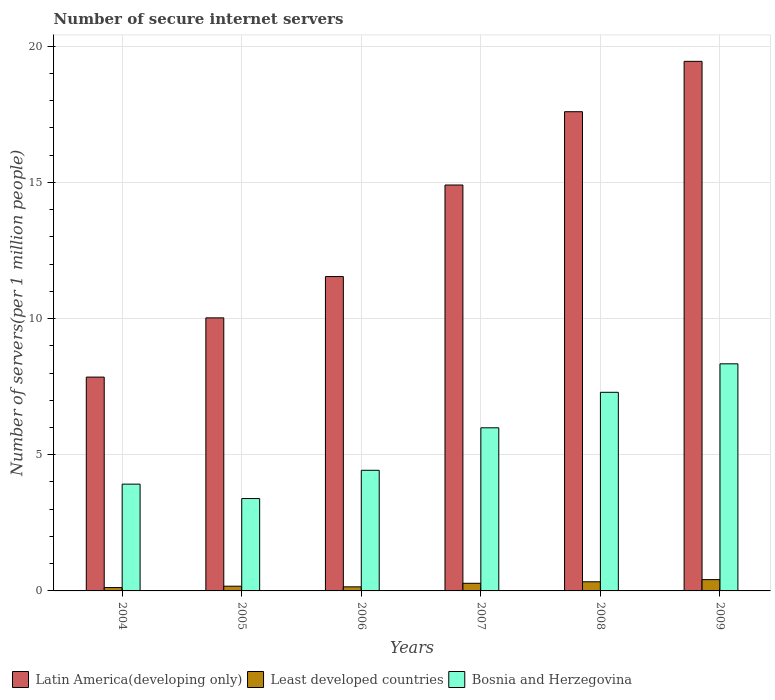How many different coloured bars are there?
Give a very brief answer. 3. Are the number of bars per tick equal to the number of legend labels?
Your response must be concise. Yes. In how many cases, is the number of bars for a given year not equal to the number of legend labels?
Make the answer very short. 0. What is the number of secure internet servers in Latin America(developing only) in 2005?
Provide a succinct answer. 10.03. Across all years, what is the maximum number of secure internet servers in Bosnia and Herzegovina?
Your answer should be compact. 8.34. Across all years, what is the minimum number of secure internet servers in Bosnia and Herzegovina?
Provide a short and direct response. 3.39. In which year was the number of secure internet servers in Least developed countries minimum?
Keep it short and to the point. 2004. What is the total number of secure internet servers in Least developed countries in the graph?
Your response must be concise. 1.48. What is the difference between the number of secure internet servers in Least developed countries in 2004 and that in 2006?
Make the answer very short. -0.03. What is the difference between the number of secure internet servers in Least developed countries in 2008 and the number of secure internet servers in Bosnia and Herzegovina in 2009?
Provide a short and direct response. -8. What is the average number of secure internet servers in Latin America(developing only) per year?
Your answer should be very brief. 13.56. In the year 2004, what is the difference between the number of secure internet servers in Latin America(developing only) and number of secure internet servers in Least developed countries?
Make the answer very short. 7.73. In how many years, is the number of secure internet servers in Latin America(developing only) greater than 4?
Your answer should be compact. 6. What is the ratio of the number of secure internet servers in Least developed countries in 2005 to that in 2008?
Provide a short and direct response. 0.52. What is the difference between the highest and the second highest number of secure internet servers in Least developed countries?
Your response must be concise. 0.08. What is the difference between the highest and the lowest number of secure internet servers in Latin America(developing only)?
Your answer should be compact. 11.59. What does the 1st bar from the left in 2005 represents?
Ensure brevity in your answer.  Latin America(developing only). What does the 1st bar from the right in 2006 represents?
Your answer should be compact. Bosnia and Herzegovina. How many bars are there?
Ensure brevity in your answer.  18. Does the graph contain any zero values?
Make the answer very short. No. What is the title of the graph?
Your answer should be very brief. Number of secure internet servers. What is the label or title of the X-axis?
Your answer should be very brief. Years. What is the label or title of the Y-axis?
Make the answer very short. Number of servers(per 1 million people). What is the Number of servers(per 1 million people) of Latin America(developing only) in 2004?
Offer a terse response. 7.85. What is the Number of servers(per 1 million people) of Least developed countries in 2004?
Your answer should be compact. 0.12. What is the Number of servers(per 1 million people) in Bosnia and Herzegovina in 2004?
Your answer should be compact. 3.92. What is the Number of servers(per 1 million people) in Latin America(developing only) in 2005?
Your answer should be very brief. 10.03. What is the Number of servers(per 1 million people) of Least developed countries in 2005?
Keep it short and to the point. 0.17. What is the Number of servers(per 1 million people) in Bosnia and Herzegovina in 2005?
Your answer should be compact. 3.39. What is the Number of servers(per 1 million people) in Latin America(developing only) in 2006?
Provide a succinct answer. 11.54. What is the Number of servers(per 1 million people) of Least developed countries in 2006?
Ensure brevity in your answer.  0.15. What is the Number of servers(per 1 million people) of Bosnia and Herzegovina in 2006?
Ensure brevity in your answer.  4.43. What is the Number of servers(per 1 million people) of Latin America(developing only) in 2007?
Keep it short and to the point. 14.9. What is the Number of servers(per 1 million people) in Least developed countries in 2007?
Provide a succinct answer. 0.28. What is the Number of servers(per 1 million people) of Bosnia and Herzegovina in 2007?
Offer a terse response. 5.99. What is the Number of servers(per 1 million people) in Latin America(developing only) in 2008?
Provide a short and direct response. 17.59. What is the Number of servers(per 1 million people) in Least developed countries in 2008?
Make the answer very short. 0.34. What is the Number of servers(per 1 million people) of Bosnia and Herzegovina in 2008?
Provide a short and direct response. 7.29. What is the Number of servers(per 1 million people) of Latin America(developing only) in 2009?
Make the answer very short. 19.44. What is the Number of servers(per 1 million people) in Least developed countries in 2009?
Your answer should be very brief. 0.42. What is the Number of servers(per 1 million people) of Bosnia and Herzegovina in 2009?
Your answer should be very brief. 8.34. Across all years, what is the maximum Number of servers(per 1 million people) in Latin America(developing only)?
Offer a terse response. 19.44. Across all years, what is the maximum Number of servers(per 1 million people) of Least developed countries?
Offer a very short reply. 0.42. Across all years, what is the maximum Number of servers(per 1 million people) in Bosnia and Herzegovina?
Your answer should be very brief. 8.34. Across all years, what is the minimum Number of servers(per 1 million people) of Latin America(developing only)?
Make the answer very short. 7.85. Across all years, what is the minimum Number of servers(per 1 million people) of Least developed countries?
Make the answer very short. 0.12. Across all years, what is the minimum Number of servers(per 1 million people) in Bosnia and Herzegovina?
Offer a terse response. 3.39. What is the total Number of servers(per 1 million people) in Latin America(developing only) in the graph?
Offer a very short reply. 81.36. What is the total Number of servers(per 1 million people) in Least developed countries in the graph?
Your answer should be compact. 1.48. What is the total Number of servers(per 1 million people) in Bosnia and Herzegovina in the graph?
Offer a very short reply. 33.36. What is the difference between the Number of servers(per 1 million people) in Latin America(developing only) in 2004 and that in 2005?
Ensure brevity in your answer.  -2.17. What is the difference between the Number of servers(per 1 million people) in Least developed countries in 2004 and that in 2005?
Keep it short and to the point. -0.05. What is the difference between the Number of servers(per 1 million people) in Bosnia and Herzegovina in 2004 and that in 2005?
Ensure brevity in your answer.  0.53. What is the difference between the Number of servers(per 1 million people) of Latin America(developing only) in 2004 and that in 2006?
Provide a succinct answer. -3.69. What is the difference between the Number of servers(per 1 million people) in Least developed countries in 2004 and that in 2006?
Provide a short and direct response. -0.03. What is the difference between the Number of servers(per 1 million people) of Bosnia and Herzegovina in 2004 and that in 2006?
Keep it short and to the point. -0.51. What is the difference between the Number of servers(per 1 million people) in Latin America(developing only) in 2004 and that in 2007?
Give a very brief answer. -7.05. What is the difference between the Number of servers(per 1 million people) in Least developed countries in 2004 and that in 2007?
Provide a succinct answer. -0.16. What is the difference between the Number of servers(per 1 million people) in Bosnia and Herzegovina in 2004 and that in 2007?
Your response must be concise. -2.07. What is the difference between the Number of servers(per 1 million people) of Latin America(developing only) in 2004 and that in 2008?
Give a very brief answer. -9.74. What is the difference between the Number of servers(per 1 million people) of Least developed countries in 2004 and that in 2008?
Provide a succinct answer. -0.21. What is the difference between the Number of servers(per 1 million people) in Bosnia and Herzegovina in 2004 and that in 2008?
Provide a short and direct response. -3.37. What is the difference between the Number of servers(per 1 million people) in Latin America(developing only) in 2004 and that in 2009?
Provide a succinct answer. -11.59. What is the difference between the Number of servers(per 1 million people) in Least developed countries in 2004 and that in 2009?
Offer a terse response. -0.29. What is the difference between the Number of servers(per 1 million people) of Bosnia and Herzegovina in 2004 and that in 2009?
Offer a terse response. -4.42. What is the difference between the Number of servers(per 1 million people) in Latin America(developing only) in 2005 and that in 2006?
Provide a succinct answer. -1.52. What is the difference between the Number of servers(per 1 million people) of Least developed countries in 2005 and that in 2006?
Offer a terse response. 0.02. What is the difference between the Number of servers(per 1 million people) of Bosnia and Herzegovina in 2005 and that in 2006?
Your response must be concise. -1.04. What is the difference between the Number of servers(per 1 million people) in Latin America(developing only) in 2005 and that in 2007?
Keep it short and to the point. -4.88. What is the difference between the Number of servers(per 1 million people) in Least developed countries in 2005 and that in 2007?
Provide a succinct answer. -0.11. What is the difference between the Number of servers(per 1 million people) in Bosnia and Herzegovina in 2005 and that in 2007?
Your answer should be compact. -2.6. What is the difference between the Number of servers(per 1 million people) in Latin America(developing only) in 2005 and that in 2008?
Your answer should be compact. -7.57. What is the difference between the Number of servers(per 1 million people) in Least developed countries in 2005 and that in 2008?
Your answer should be compact. -0.16. What is the difference between the Number of servers(per 1 million people) of Bosnia and Herzegovina in 2005 and that in 2008?
Your response must be concise. -3.9. What is the difference between the Number of servers(per 1 million people) of Latin America(developing only) in 2005 and that in 2009?
Your answer should be very brief. -9.42. What is the difference between the Number of servers(per 1 million people) in Least developed countries in 2005 and that in 2009?
Offer a terse response. -0.24. What is the difference between the Number of servers(per 1 million people) of Bosnia and Herzegovina in 2005 and that in 2009?
Offer a terse response. -4.95. What is the difference between the Number of servers(per 1 million people) of Latin America(developing only) in 2006 and that in 2007?
Ensure brevity in your answer.  -3.36. What is the difference between the Number of servers(per 1 million people) of Least developed countries in 2006 and that in 2007?
Ensure brevity in your answer.  -0.13. What is the difference between the Number of servers(per 1 million people) of Bosnia and Herzegovina in 2006 and that in 2007?
Give a very brief answer. -1.56. What is the difference between the Number of servers(per 1 million people) in Latin America(developing only) in 2006 and that in 2008?
Provide a short and direct response. -6.05. What is the difference between the Number of servers(per 1 million people) in Least developed countries in 2006 and that in 2008?
Your response must be concise. -0.19. What is the difference between the Number of servers(per 1 million people) of Bosnia and Herzegovina in 2006 and that in 2008?
Your answer should be compact. -2.86. What is the difference between the Number of servers(per 1 million people) of Latin America(developing only) in 2006 and that in 2009?
Provide a short and direct response. -7.9. What is the difference between the Number of servers(per 1 million people) in Least developed countries in 2006 and that in 2009?
Offer a very short reply. -0.27. What is the difference between the Number of servers(per 1 million people) of Bosnia and Herzegovina in 2006 and that in 2009?
Ensure brevity in your answer.  -3.91. What is the difference between the Number of servers(per 1 million people) in Latin America(developing only) in 2007 and that in 2008?
Offer a terse response. -2.69. What is the difference between the Number of servers(per 1 million people) in Least developed countries in 2007 and that in 2008?
Your response must be concise. -0.06. What is the difference between the Number of servers(per 1 million people) of Bosnia and Herzegovina in 2007 and that in 2008?
Offer a very short reply. -1.3. What is the difference between the Number of servers(per 1 million people) in Latin America(developing only) in 2007 and that in 2009?
Keep it short and to the point. -4.54. What is the difference between the Number of servers(per 1 million people) in Least developed countries in 2007 and that in 2009?
Offer a very short reply. -0.13. What is the difference between the Number of servers(per 1 million people) of Bosnia and Herzegovina in 2007 and that in 2009?
Give a very brief answer. -2.35. What is the difference between the Number of servers(per 1 million people) in Latin America(developing only) in 2008 and that in 2009?
Your answer should be very brief. -1.85. What is the difference between the Number of servers(per 1 million people) in Least developed countries in 2008 and that in 2009?
Provide a short and direct response. -0.08. What is the difference between the Number of servers(per 1 million people) of Bosnia and Herzegovina in 2008 and that in 2009?
Provide a succinct answer. -1.05. What is the difference between the Number of servers(per 1 million people) of Latin America(developing only) in 2004 and the Number of servers(per 1 million people) of Least developed countries in 2005?
Your response must be concise. 7.68. What is the difference between the Number of servers(per 1 million people) of Latin America(developing only) in 2004 and the Number of servers(per 1 million people) of Bosnia and Herzegovina in 2005?
Your answer should be compact. 4.46. What is the difference between the Number of servers(per 1 million people) in Least developed countries in 2004 and the Number of servers(per 1 million people) in Bosnia and Herzegovina in 2005?
Keep it short and to the point. -3.27. What is the difference between the Number of servers(per 1 million people) of Latin America(developing only) in 2004 and the Number of servers(per 1 million people) of Least developed countries in 2006?
Give a very brief answer. 7.7. What is the difference between the Number of servers(per 1 million people) of Latin America(developing only) in 2004 and the Number of servers(per 1 million people) of Bosnia and Herzegovina in 2006?
Offer a very short reply. 3.42. What is the difference between the Number of servers(per 1 million people) in Least developed countries in 2004 and the Number of servers(per 1 million people) in Bosnia and Herzegovina in 2006?
Your answer should be very brief. -4.31. What is the difference between the Number of servers(per 1 million people) of Latin America(developing only) in 2004 and the Number of servers(per 1 million people) of Least developed countries in 2007?
Provide a short and direct response. 7.57. What is the difference between the Number of servers(per 1 million people) of Latin America(developing only) in 2004 and the Number of servers(per 1 million people) of Bosnia and Herzegovina in 2007?
Keep it short and to the point. 1.86. What is the difference between the Number of servers(per 1 million people) in Least developed countries in 2004 and the Number of servers(per 1 million people) in Bosnia and Herzegovina in 2007?
Offer a terse response. -5.87. What is the difference between the Number of servers(per 1 million people) in Latin America(developing only) in 2004 and the Number of servers(per 1 million people) in Least developed countries in 2008?
Make the answer very short. 7.52. What is the difference between the Number of servers(per 1 million people) in Latin America(developing only) in 2004 and the Number of servers(per 1 million people) in Bosnia and Herzegovina in 2008?
Make the answer very short. 0.56. What is the difference between the Number of servers(per 1 million people) of Least developed countries in 2004 and the Number of servers(per 1 million people) of Bosnia and Herzegovina in 2008?
Your answer should be compact. -7.17. What is the difference between the Number of servers(per 1 million people) in Latin America(developing only) in 2004 and the Number of servers(per 1 million people) in Least developed countries in 2009?
Provide a succinct answer. 7.44. What is the difference between the Number of servers(per 1 million people) in Latin America(developing only) in 2004 and the Number of servers(per 1 million people) in Bosnia and Herzegovina in 2009?
Keep it short and to the point. -0.49. What is the difference between the Number of servers(per 1 million people) in Least developed countries in 2004 and the Number of servers(per 1 million people) in Bosnia and Herzegovina in 2009?
Offer a terse response. -8.21. What is the difference between the Number of servers(per 1 million people) of Latin America(developing only) in 2005 and the Number of servers(per 1 million people) of Least developed countries in 2006?
Your answer should be very brief. 9.88. What is the difference between the Number of servers(per 1 million people) of Latin America(developing only) in 2005 and the Number of servers(per 1 million people) of Bosnia and Herzegovina in 2006?
Provide a succinct answer. 5.6. What is the difference between the Number of servers(per 1 million people) of Least developed countries in 2005 and the Number of servers(per 1 million people) of Bosnia and Herzegovina in 2006?
Ensure brevity in your answer.  -4.26. What is the difference between the Number of servers(per 1 million people) in Latin America(developing only) in 2005 and the Number of servers(per 1 million people) in Least developed countries in 2007?
Make the answer very short. 9.74. What is the difference between the Number of servers(per 1 million people) of Latin America(developing only) in 2005 and the Number of servers(per 1 million people) of Bosnia and Herzegovina in 2007?
Provide a short and direct response. 4.04. What is the difference between the Number of servers(per 1 million people) in Least developed countries in 2005 and the Number of servers(per 1 million people) in Bosnia and Herzegovina in 2007?
Your answer should be very brief. -5.82. What is the difference between the Number of servers(per 1 million people) in Latin America(developing only) in 2005 and the Number of servers(per 1 million people) in Least developed countries in 2008?
Your answer should be very brief. 9.69. What is the difference between the Number of servers(per 1 million people) of Latin America(developing only) in 2005 and the Number of servers(per 1 million people) of Bosnia and Herzegovina in 2008?
Ensure brevity in your answer.  2.73. What is the difference between the Number of servers(per 1 million people) in Least developed countries in 2005 and the Number of servers(per 1 million people) in Bosnia and Herzegovina in 2008?
Give a very brief answer. -7.12. What is the difference between the Number of servers(per 1 million people) of Latin America(developing only) in 2005 and the Number of servers(per 1 million people) of Least developed countries in 2009?
Your answer should be very brief. 9.61. What is the difference between the Number of servers(per 1 million people) in Latin America(developing only) in 2005 and the Number of servers(per 1 million people) in Bosnia and Herzegovina in 2009?
Ensure brevity in your answer.  1.69. What is the difference between the Number of servers(per 1 million people) of Least developed countries in 2005 and the Number of servers(per 1 million people) of Bosnia and Herzegovina in 2009?
Make the answer very short. -8.16. What is the difference between the Number of servers(per 1 million people) of Latin America(developing only) in 2006 and the Number of servers(per 1 million people) of Least developed countries in 2007?
Your answer should be very brief. 11.26. What is the difference between the Number of servers(per 1 million people) in Latin America(developing only) in 2006 and the Number of servers(per 1 million people) in Bosnia and Herzegovina in 2007?
Keep it short and to the point. 5.55. What is the difference between the Number of servers(per 1 million people) in Least developed countries in 2006 and the Number of servers(per 1 million people) in Bosnia and Herzegovina in 2007?
Keep it short and to the point. -5.84. What is the difference between the Number of servers(per 1 million people) of Latin America(developing only) in 2006 and the Number of servers(per 1 million people) of Least developed countries in 2008?
Provide a short and direct response. 11.21. What is the difference between the Number of servers(per 1 million people) of Latin America(developing only) in 2006 and the Number of servers(per 1 million people) of Bosnia and Herzegovina in 2008?
Your answer should be compact. 4.25. What is the difference between the Number of servers(per 1 million people) of Least developed countries in 2006 and the Number of servers(per 1 million people) of Bosnia and Herzegovina in 2008?
Your answer should be compact. -7.14. What is the difference between the Number of servers(per 1 million people) in Latin America(developing only) in 2006 and the Number of servers(per 1 million people) in Least developed countries in 2009?
Keep it short and to the point. 11.13. What is the difference between the Number of servers(per 1 million people) of Latin America(developing only) in 2006 and the Number of servers(per 1 million people) of Bosnia and Herzegovina in 2009?
Your response must be concise. 3.2. What is the difference between the Number of servers(per 1 million people) of Least developed countries in 2006 and the Number of servers(per 1 million people) of Bosnia and Herzegovina in 2009?
Your response must be concise. -8.19. What is the difference between the Number of servers(per 1 million people) in Latin America(developing only) in 2007 and the Number of servers(per 1 million people) in Least developed countries in 2008?
Your response must be concise. 14.57. What is the difference between the Number of servers(per 1 million people) of Latin America(developing only) in 2007 and the Number of servers(per 1 million people) of Bosnia and Herzegovina in 2008?
Give a very brief answer. 7.61. What is the difference between the Number of servers(per 1 million people) in Least developed countries in 2007 and the Number of servers(per 1 million people) in Bosnia and Herzegovina in 2008?
Make the answer very short. -7.01. What is the difference between the Number of servers(per 1 million people) of Latin America(developing only) in 2007 and the Number of servers(per 1 million people) of Least developed countries in 2009?
Offer a terse response. 14.49. What is the difference between the Number of servers(per 1 million people) in Latin America(developing only) in 2007 and the Number of servers(per 1 million people) in Bosnia and Herzegovina in 2009?
Ensure brevity in your answer.  6.56. What is the difference between the Number of servers(per 1 million people) in Least developed countries in 2007 and the Number of servers(per 1 million people) in Bosnia and Herzegovina in 2009?
Provide a short and direct response. -8.06. What is the difference between the Number of servers(per 1 million people) of Latin America(developing only) in 2008 and the Number of servers(per 1 million people) of Least developed countries in 2009?
Your response must be concise. 17.18. What is the difference between the Number of servers(per 1 million people) of Latin America(developing only) in 2008 and the Number of servers(per 1 million people) of Bosnia and Herzegovina in 2009?
Your answer should be very brief. 9.26. What is the difference between the Number of servers(per 1 million people) in Least developed countries in 2008 and the Number of servers(per 1 million people) in Bosnia and Herzegovina in 2009?
Ensure brevity in your answer.  -8. What is the average Number of servers(per 1 million people) of Latin America(developing only) per year?
Make the answer very short. 13.56. What is the average Number of servers(per 1 million people) in Least developed countries per year?
Offer a very short reply. 0.25. What is the average Number of servers(per 1 million people) in Bosnia and Herzegovina per year?
Provide a short and direct response. 5.56. In the year 2004, what is the difference between the Number of servers(per 1 million people) of Latin America(developing only) and Number of servers(per 1 million people) of Least developed countries?
Ensure brevity in your answer.  7.73. In the year 2004, what is the difference between the Number of servers(per 1 million people) of Latin America(developing only) and Number of servers(per 1 million people) of Bosnia and Herzegovina?
Keep it short and to the point. 3.93. In the year 2004, what is the difference between the Number of servers(per 1 million people) of Least developed countries and Number of servers(per 1 million people) of Bosnia and Herzegovina?
Offer a terse response. -3.8. In the year 2005, what is the difference between the Number of servers(per 1 million people) of Latin America(developing only) and Number of servers(per 1 million people) of Least developed countries?
Provide a succinct answer. 9.85. In the year 2005, what is the difference between the Number of servers(per 1 million people) in Latin America(developing only) and Number of servers(per 1 million people) in Bosnia and Herzegovina?
Your answer should be very brief. 6.63. In the year 2005, what is the difference between the Number of servers(per 1 million people) of Least developed countries and Number of servers(per 1 million people) of Bosnia and Herzegovina?
Your response must be concise. -3.22. In the year 2006, what is the difference between the Number of servers(per 1 million people) of Latin America(developing only) and Number of servers(per 1 million people) of Least developed countries?
Offer a very short reply. 11.39. In the year 2006, what is the difference between the Number of servers(per 1 million people) of Latin America(developing only) and Number of servers(per 1 million people) of Bosnia and Herzegovina?
Your response must be concise. 7.11. In the year 2006, what is the difference between the Number of servers(per 1 million people) of Least developed countries and Number of servers(per 1 million people) of Bosnia and Herzegovina?
Your answer should be compact. -4.28. In the year 2007, what is the difference between the Number of servers(per 1 million people) in Latin America(developing only) and Number of servers(per 1 million people) in Least developed countries?
Your response must be concise. 14.62. In the year 2007, what is the difference between the Number of servers(per 1 million people) in Latin America(developing only) and Number of servers(per 1 million people) in Bosnia and Herzegovina?
Your answer should be compact. 8.91. In the year 2007, what is the difference between the Number of servers(per 1 million people) in Least developed countries and Number of servers(per 1 million people) in Bosnia and Herzegovina?
Provide a succinct answer. -5.71. In the year 2008, what is the difference between the Number of servers(per 1 million people) in Latin America(developing only) and Number of servers(per 1 million people) in Least developed countries?
Offer a very short reply. 17.26. In the year 2008, what is the difference between the Number of servers(per 1 million people) in Latin America(developing only) and Number of servers(per 1 million people) in Bosnia and Herzegovina?
Provide a short and direct response. 10.3. In the year 2008, what is the difference between the Number of servers(per 1 million people) of Least developed countries and Number of servers(per 1 million people) of Bosnia and Herzegovina?
Your response must be concise. -6.96. In the year 2009, what is the difference between the Number of servers(per 1 million people) in Latin America(developing only) and Number of servers(per 1 million people) in Least developed countries?
Your answer should be compact. 19.03. In the year 2009, what is the difference between the Number of servers(per 1 million people) in Latin America(developing only) and Number of servers(per 1 million people) in Bosnia and Herzegovina?
Offer a very short reply. 11.1. In the year 2009, what is the difference between the Number of servers(per 1 million people) in Least developed countries and Number of servers(per 1 million people) in Bosnia and Herzegovina?
Offer a terse response. -7.92. What is the ratio of the Number of servers(per 1 million people) of Latin America(developing only) in 2004 to that in 2005?
Your response must be concise. 0.78. What is the ratio of the Number of servers(per 1 million people) in Least developed countries in 2004 to that in 2005?
Your response must be concise. 0.71. What is the ratio of the Number of servers(per 1 million people) in Bosnia and Herzegovina in 2004 to that in 2005?
Provide a short and direct response. 1.16. What is the ratio of the Number of servers(per 1 million people) in Latin America(developing only) in 2004 to that in 2006?
Provide a short and direct response. 0.68. What is the ratio of the Number of servers(per 1 million people) in Least developed countries in 2004 to that in 2006?
Your answer should be very brief. 0.83. What is the ratio of the Number of servers(per 1 million people) in Bosnia and Herzegovina in 2004 to that in 2006?
Provide a succinct answer. 0.89. What is the ratio of the Number of servers(per 1 million people) in Latin America(developing only) in 2004 to that in 2007?
Offer a very short reply. 0.53. What is the ratio of the Number of servers(per 1 million people) of Least developed countries in 2004 to that in 2007?
Make the answer very short. 0.44. What is the ratio of the Number of servers(per 1 million people) in Bosnia and Herzegovina in 2004 to that in 2007?
Give a very brief answer. 0.65. What is the ratio of the Number of servers(per 1 million people) of Latin America(developing only) in 2004 to that in 2008?
Offer a very short reply. 0.45. What is the ratio of the Number of servers(per 1 million people) in Least developed countries in 2004 to that in 2008?
Make the answer very short. 0.37. What is the ratio of the Number of servers(per 1 million people) of Bosnia and Herzegovina in 2004 to that in 2008?
Give a very brief answer. 0.54. What is the ratio of the Number of servers(per 1 million people) of Latin America(developing only) in 2004 to that in 2009?
Provide a short and direct response. 0.4. What is the ratio of the Number of servers(per 1 million people) of Least developed countries in 2004 to that in 2009?
Offer a terse response. 0.3. What is the ratio of the Number of servers(per 1 million people) in Bosnia and Herzegovina in 2004 to that in 2009?
Your answer should be compact. 0.47. What is the ratio of the Number of servers(per 1 million people) in Latin America(developing only) in 2005 to that in 2006?
Provide a succinct answer. 0.87. What is the ratio of the Number of servers(per 1 million people) of Least developed countries in 2005 to that in 2006?
Offer a terse response. 1.16. What is the ratio of the Number of servers(per 1 million people) of Bosnia and Herzegovina in 2005 to that in 2006?
Offer a very short reply. 0.77. What is the ratio of the Number of servers(per 1 million people) of Latin America(developing only) in 2005 to that in 2007?
Provide a succinct answer. 0.67. What is the ratio of the Number of servers(per 1 million people) in Least developed countries in 2005 to that in 2007?
Your answer should be very brief. 0.62. What is the ratio of the Number of servers(per 1 million people) of Bosnia and Herzegovina in 2005 to that in 2007?
Provide a short and direct response. 0.57. What is the ratio of the Number of servers(per 1 million people) of Latin America(developing only) in 2005 to that in 2008?
Offer a very short reply. 0.57. What is the ratio of the Number of servers(per 1 million people) in Least developed countries in 2005 to that in 2008?
Your answer should be compact. 0.52. What is the ratio of the Number of servers(per 1 million people) in Bosnia and Herzegovina in 2005 to that in 2008?
Keep it short and to the point. 0.47. What is the ratio of the Number of servers(per 1 million people) in Latin America(developing only) in 2005 to that in 2009?
Give a very brief answer. 0.52. What is the ratio of the Number of servers(per 1 million people) of Least developed countries in 2005 to that in 2009?
Your answer should be very brief. 0.42. What is the ratio of the Number of servers(per 1 million people) of Bosnia and Herzegovina in 2005 to that in 2009?
Make the answer very short. 0.41. What is the ratio of the Number of servers(per 1 million people) of Latin America(developing only) in 2006 to that in 2007?
Provide a short and direct response. 0.77. What is the ratio of the Number of servers(per 1 million people) of Least developed countries in 2006 to that in 2007?
Your response must be concise. 0.53. What is the ratio of the Number of servers(per 1 million people) in Bosnia and Herzegovina in 2006 to that in 2007?
Ensure brevity in your answer.  0.74. What is the ratio of the Number of servers(per 1 million people) of Latin America(developing only) in 2006 to that in 2008?
Offer a terse response. 0.66. What is the ratio of the Number of servers(per 1 million people) of Least developed countries in 2006 to that in 2008?
Offer a terse response. 0.45. What is the ratio of the Number of servers(per 1 million people) in Bosnia and Herzegovina in 2006 to that in 2008?
Your answer should be compact. 0.61. What is the ratio of the Number of servers(per 1 million people) of Latin America(developing only) in 2006 to that in 2009?
Give a very brief answer. 0.59. What is the ratio of the Number of servers(per 1 million people) of Least developed countries in 2006 to that in 2009?
Offer a very short reply. 0.36. What is the ratio of the Number of servers(per 1 million people) in Bosnia and Herzegovina in 2006 to that in 2009?
Your response must be concise. 0.53. What is the ratio of the Number of servers(per 1 million people) in Latin America(developing only) in 2007 to that in 2008?
Your answer should be compact. 0.85. What is the ratio of the Number of servers(per 1 million people) in Least developed countries in 2007 to that in 2008?
Provide a short and direct response. 0.84. What is the ratio of the Number of servers(per 1 million people) of Bosnia and Herzegovina in 2007 to that in 2008?
Your response must be concise. 0.82. What is the ratio of the Number of servers(per 1 million people) in Latin America(developing only) in 2007 to that in 2009?
Your answer should be very brief. 0.77. What is the ratio of the Number of servers(per 1 million people) of Least developed countries in 2007 to that in 2009?
Provide a short and direct response. 0.68. What is the ratio of the Number of servers(per 1 million people) in Bosnia and Herzegovina in 2007 to that in 2009?
Provide a succinct answer. 0.72. What is the ratio of the Number of servers(per 1 million people) of Latin America(developing only) in 2008 to that in 2009?
Give a very brief answer. 0.9. What is the ratio of the Number of servers(per 1 million people) of Least developed countries in 2008 to that in 2009?
Your answer should be very brief. 0.81. What is the ratio of the Number of servers(per 1 million people) of Bosnia and Herzegovina in 2008 to that in 2009?
Your response must be concise. 0.87. What is the difference between the highest and the second highest Number of servers(per 1 million people) in Latin America(developing only)?
Make the answer very short. 1.85. What is the difference between the highest and the second highest Number of servers(per 1 million people) of Least developed countries?
Your response must be concise. 0.08. What is the difference between the highest and the second highest Number of servers(per 1 million people) in Bosnia and Herzegovina?
Keep it short and to the point. 1.05. What is the difference between the highest and the lowest Number of servers(per 1 million people) of Latin America(developing only)?
Offer a very short reply. 11.59. What is the difference between the highest and the lowest Number of servers(per 1 million people) of Least developed countries?
Provide a short and direct response. 0.29. What is the difference between the highest and the lowest Number of servers(per 1 million people) in Bosnia and Herzegovina?
Make the answer very short. 4.95. 